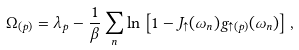Convert formula to latex. <formula><loc_0><loc_0><loc_500><loc_500>\Omega _ { ( p ) } = \lambda _ { p } - \frac { 1 } { \beta } \sum _ { n } \ln \left [ 1 - J _ { \uparrow } ( \omega _ { n } ) g _ { \uparrow ( p ) } ( \omega _ { n } ) \right ] ,</formula> 